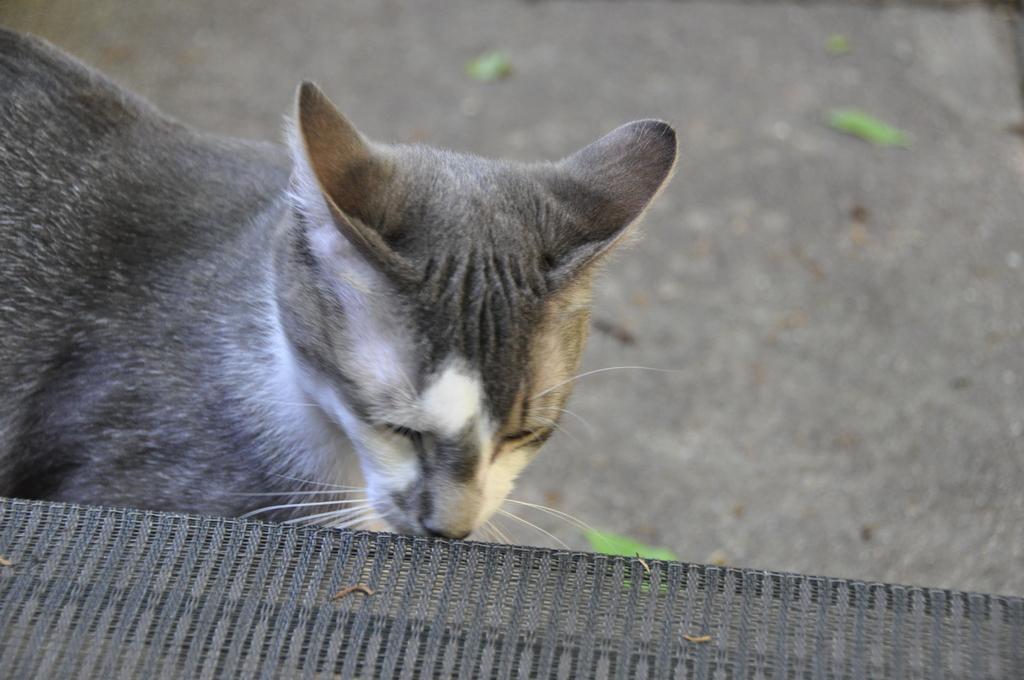What animal can be seen in the image? There is a cat in the image. Where is the cat located? The cat is on the road. What is the cat doing in the image? The cat is smelling something. What is the cat smelling, and where is it located? The object the cat is smelling is in front of it. What type of glue is the cat using to stick its sister to the suit in the image? There is no glue, suit, or sister present in the image; it only features a cat on the road smelling something. 